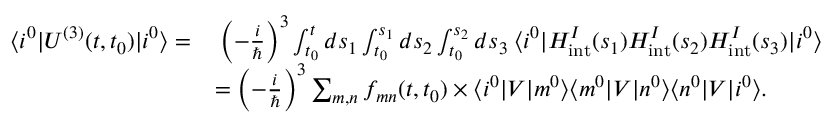Convert formula to latex. <formula><loc_0><loc_0><loc_500><loc_500>\begin{array} { r l } { \langle i ^ { 0 } | U ^ { ( 3 ) } ( t , t _ { 0 } ) | i ^ { 0 } \rangle = } & { \, \left ( - \frac { i } { } \right ) ^ { 3 } \int _ { t _ { 0 } } ^ { t } d s _ { 1 } \int _ { t _ { 0 } } ^ { s _ { 1 } } d s _ { 2 } \int _ { t _ { 0 } } ^ { s _ { 2 } } d s _ { 3 } \, \langle i ^ { 0 } | H _ { i n t } ^ { I } ( s _ { 1 } ) H _ { i n t } ^ { I } ( s _ { 2 } ) H _ { i n t } ^ { I } ( s _ { 3 } ) | i ^ { 0 } \rangle } \\ & { = \left ( - \frac { i } { } \right ) ^ { 3 } \sum _ { m , n } f _ { m n } ( t , t _ { 0 } ) \times \langle i ^ { 0 } | V | m ^ { 0 } \rangle \langle m ^ { 0 } | V | n ^ { 0 } \rangle \langle n ^ { 0 } | V | i ^ { 0 } \rangle . } \end{array}</formula> 